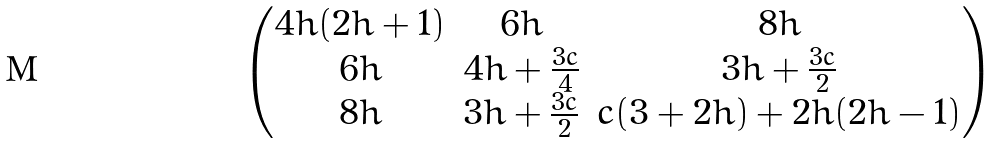Convert formula to latex. <formula><loc_0><loc_0><loc_500><loc_500>\begin{pmatrix} 4 h ( 2 h + 1 ) & 6 h & 8 h \\ 6 h & 4 h + \frac { 3 c } { 4 } & 3 h + \frac { 3 c } { 2 } \\ 8 h & 3 h + \frac { 3 c } { 2 } & c ( 3 + 2 h ) + 2 h ( 2 h - 1 ) \\ \end{pmatrix}</formula> 